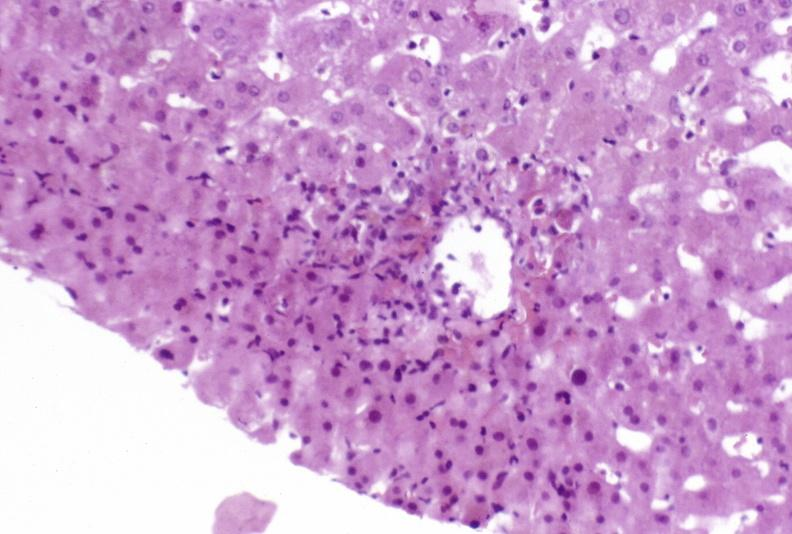what is present?
Answer the question using a single word or phrase. Hepatobiliary 